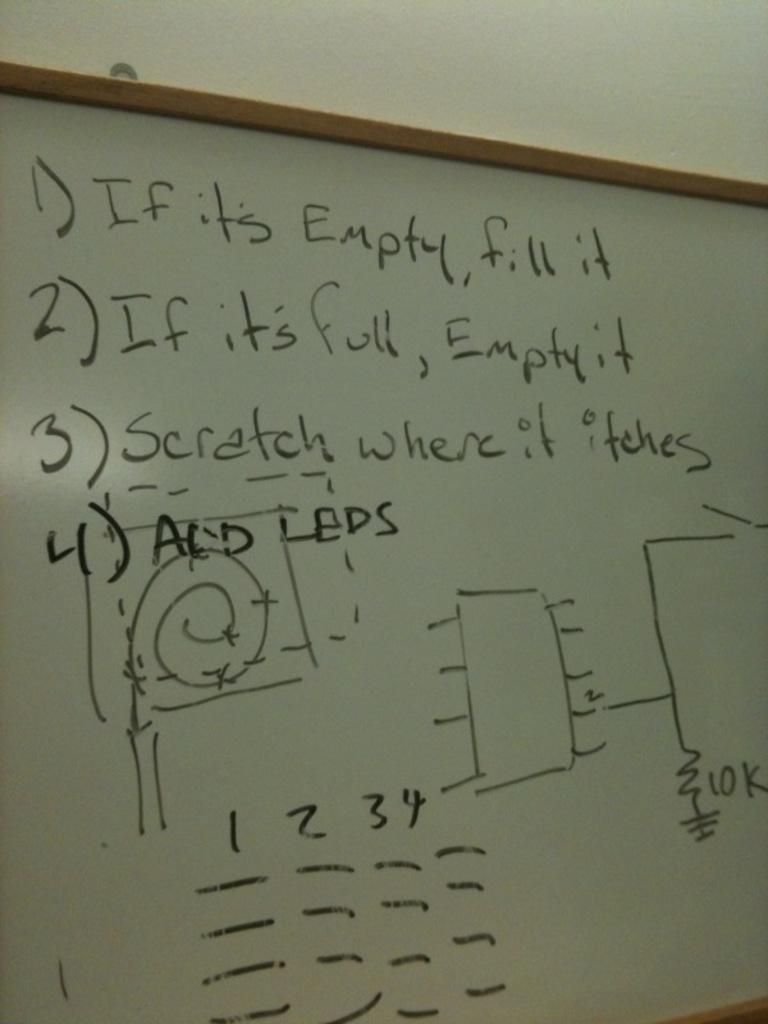What is rule number 2?
Your answer should be very brief. If it's full, empty it. What is rule 1?
Provide a succinct answer. If it's empty, fill it. 